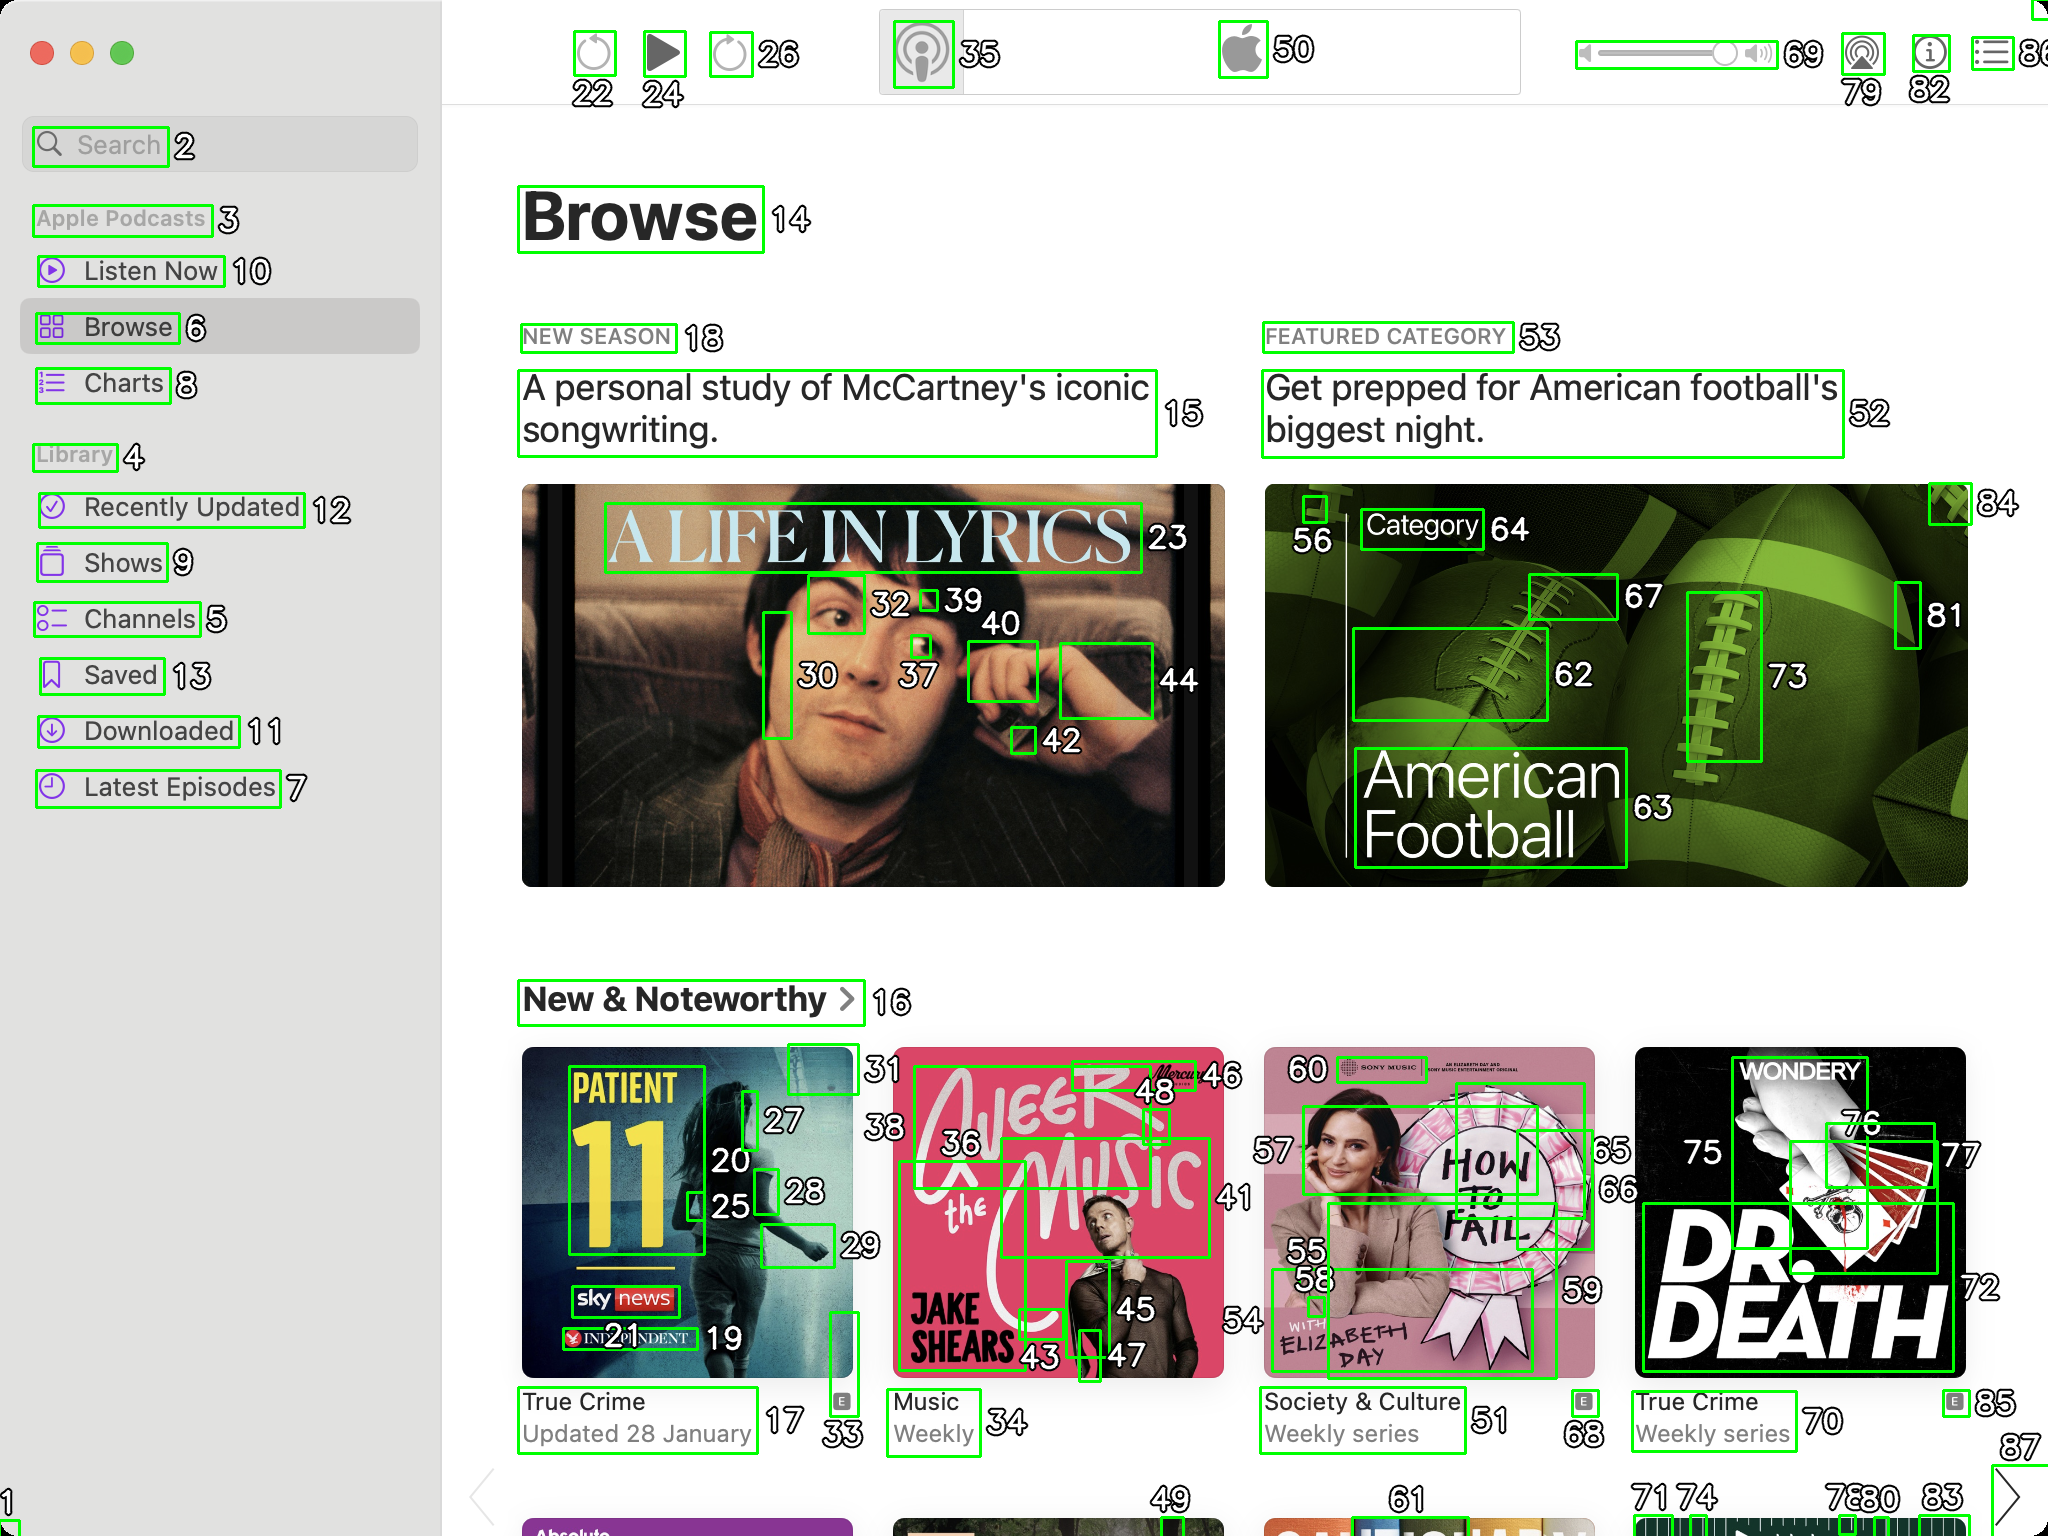You are an AI designed for image processing and segmentation analysis, particularly skilled in merging segmented regions of an image to improve accuracy and readability.

**Task Description:**
Your task is to address a user's concern with a UI screenshot of the Apple Podcasts application on MacOS. The screenshot contains multiple green boxes, each representing a UI element, with a unique white number outlined in black ranging from 1 to 88. Due to segmentation issues, some boxes that belong to the same image are divided unnaturally.

**Objective:**
Merge these segmented areas that correspond to a single UI element to create a coherent representation. The final output should be in JSON format, where each key-value pair represents the merged areas.

**Example JSON Output:**
If boxes with numbers 1, 2, and 3 should belong to the same UI element, the JSON output should be:

```json
{
    "Image A Life In Lyrics": [1, 2, 3]
}
```

**Instructions:**

- **Identify Segmented Regions:** Analyze the screenshot to identify which green boxes belong to the same UI element.
- **Merge Regions:** Group the numbers of these boxes together to represent a single UI element.
- **Output Format:** Produce the output in JSON format, with each key representing a UI element and each value being a list of the numbers of the merged boxes. If UI element contains only one box than omit that element in final result.

**Primary Objective:**
Ensure the accuracy of the merged regions based on the user's supplied image information, maintaining the integrity and structure of the UI elements in the Apple Podcasts application on MacOS. ```json
{
    "Search": [2],
    "Apple Podcasts": [3],
    "Listen Now": [10],
    "Browse": [6, 14],
    "Charts": [8],
    "Library": [4],
    "Recently Updated": [12],
    "Shows": [9],
    "Channels": [5],
    "Saved": [13],
    "Downloaded": [11],
    "Latest Episodes": [7],
    "Play Button": [22, 24],
    "Volume Control": [26, 69],
    "AirPlay": [35],
    "Apple Logo": [50],
    "A Life In Lyrics": [23, 30, 32, 37, 39, 40, 42, 44],
    "New Season": [18],
    "A personal study of McCartney's iconic songwriting.": [15],
    "Featured Category": [53],
    "Get prepped for American football's biggest night.": [52],
    "American Football": [56, 62, 63, 64, 67, 73, 81, 84],
    "New & Noteworthy": [16],
    "Patient 11": [17, 20, 25, 27, 28, 33],
    "True Crime": [19],
    "Updated 28 January": [31],
    "A Beer With The Music": [36, 43, 45, 46, 48],
    "Weekly": [34],
    "How To Fail": [55, 58, 59, 60],
    "Society & Culture": [51],
    "Weekly series": [49],
    "Dr. Death": [70, 72, 75, 76, 77],
    "True Crime Weekly series": [68],
    "Updated 28 January": [71, 74, 78, 79, 80, 82, 85]
}
``` 